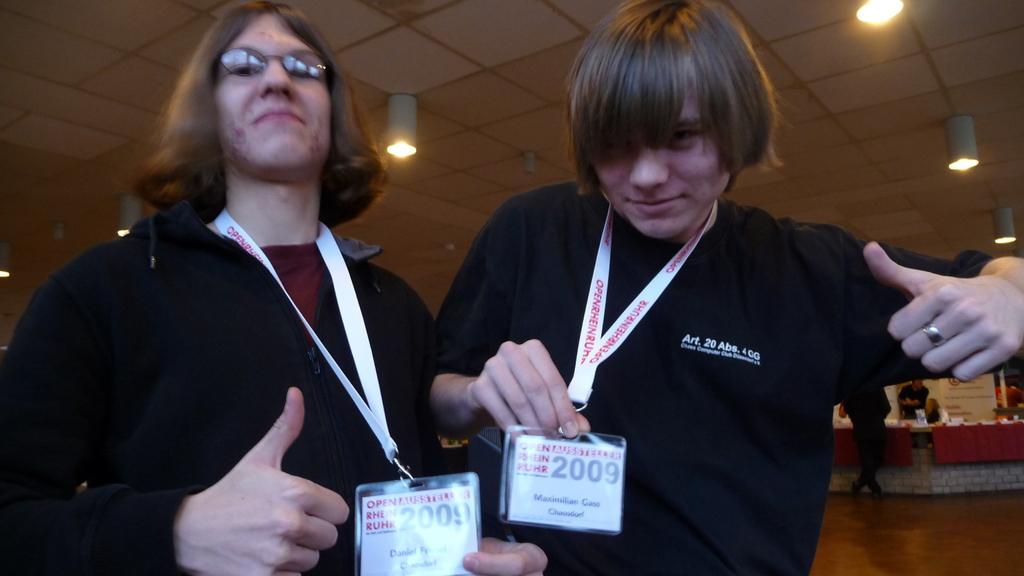In one or two sentences, can you explain what this image depicts? In this image I can see 2 people standing in the front. They are wearing black t shirt and id cards. There are lights at the top and there are other people at the back. 